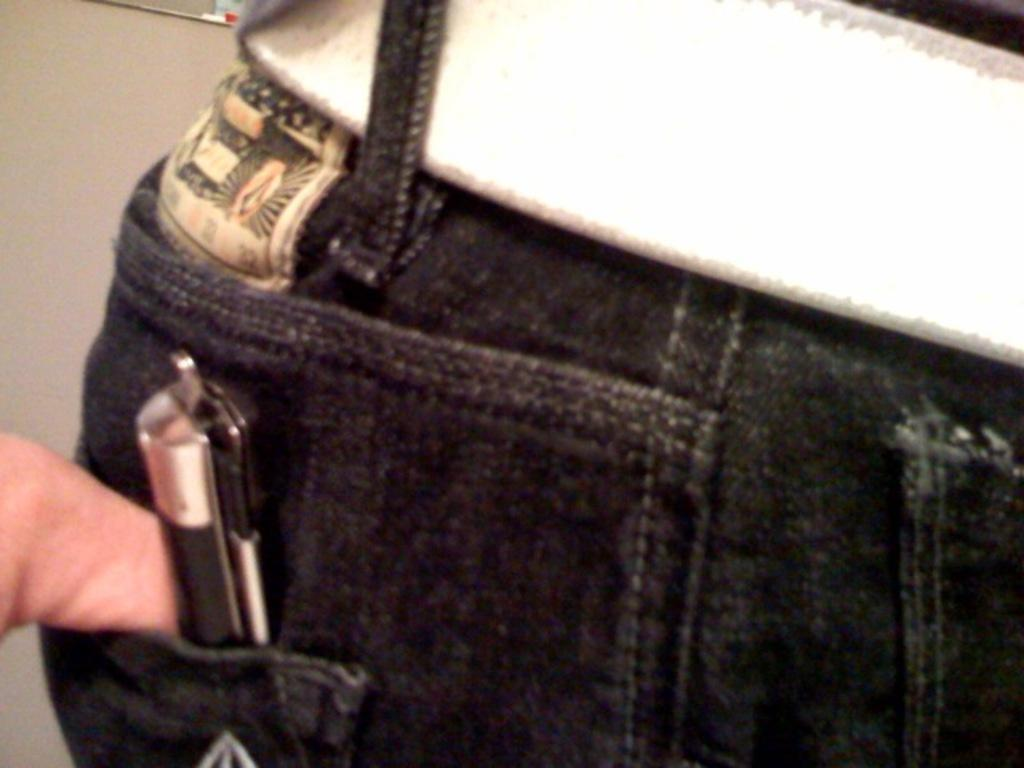What is the main subject of the image? There is a person in the image. What type of clothing is the person wearing? The person is wearing jeans. Are there any accessories visible in the image? Yes, the person is wearing a belt. What can be found in the person's pocket? The person has a pen in his pocket. What type of owl can be seen sitting on the person's shoulder in the image? There is no owl present in the image; the person is alone. What trick is the person performing in the image? There is no trick being performed in the image; the person is simply standing or posing. 